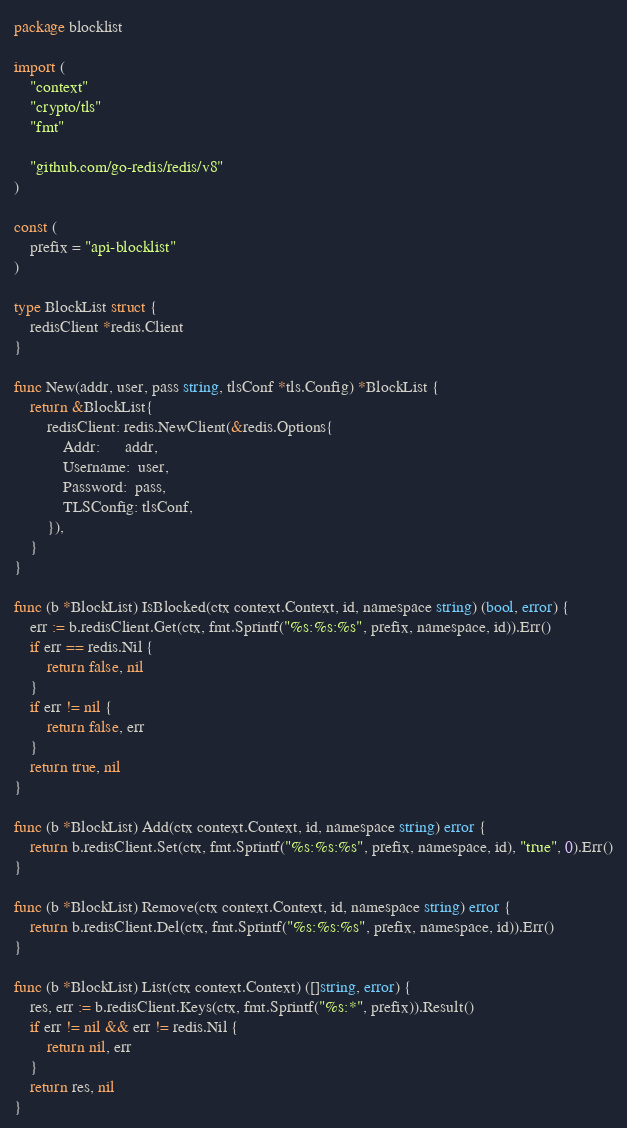<code> <loc_0><loc_0><loc_500><loc_500><_Go_>package blocklist

import (
	"context"
	"crypto/tls"
	"fmt"

	"github.com/go-redis/redis/v8"
)

const (
	prefix = "api-blocklist"
)

type BlockList struct {
	redisClient *redis.Client
}

func New(addr, user, pass string, tlsConf *tls.Config) *BlockList {
	return &BlockList{
		redisClient: redis.NewClient(&redis.Options{
			Addr:      addr,
			Username:  user,
			Password:  pass,
			TLSConfig: tlsConf,
		}),
	}
}

func (b *BlockList) IsBlocked(ctx context.Context, id, namespace string) (bool, error) {
	err := b.redisClient.Get(ctx, fmt.Sprintf("%s:%s:%s", prefix, namespace, id)).Err()
	if err == redis.Nil {
		return false, nil
	}
	if err != nil {
		return false, err
	}
	return true, nil
}

func (b *BlockList) Add(ctx context.Context, id, namespace string) error {
	return b.redisClient.Set(ctx, fmt.Sprintf("%s:%s:%s", prefix, namespace, id), "true", 0).Err()
}

func (b *BlockList) Remove(ctx context.Context, id, namespace string) error {
	return b.redisClient.Del(ctx, fmt.Sprintf("%s:%s:%s", prefix, namespace, id)).Err()
}

func (b *BlockList) List(ctx context.Context) ([]string, error) {
	res, err := b.redisClient.Keys(ctx, fmt.Sprintf("%s:*", prefix)).Result()
	if err != nil && err != redis.Nil {
		return nil, err
	}
	return res, nil
}
</code> 